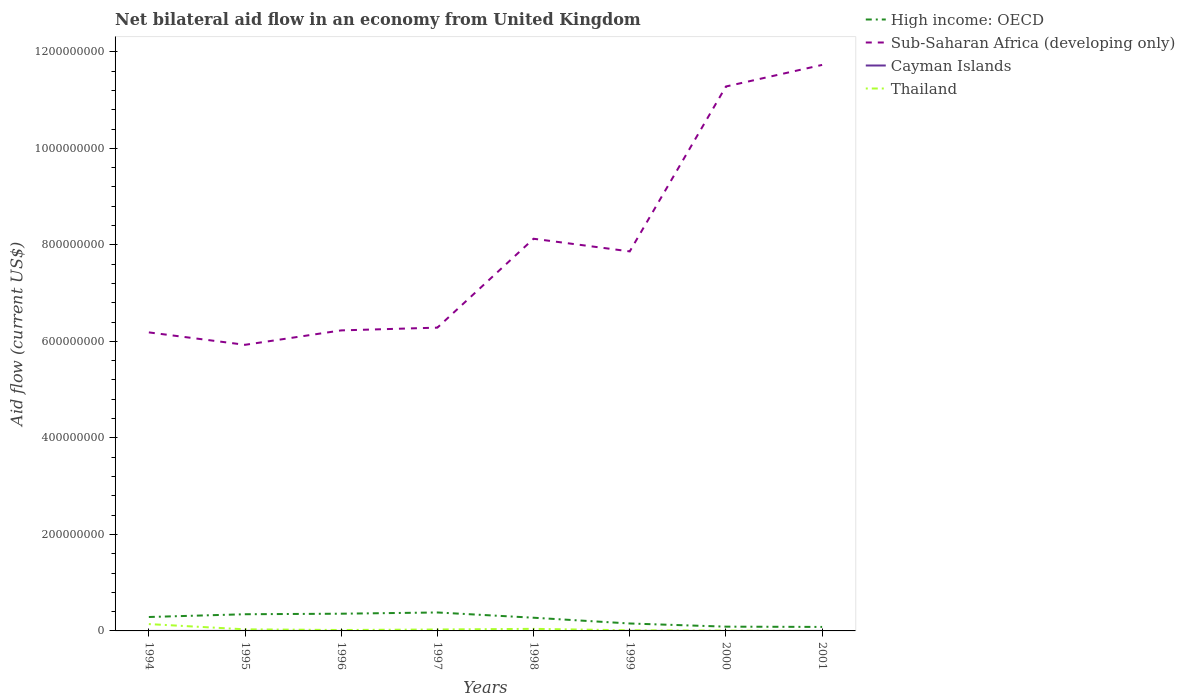How many different coloured lines are there?
Offer a very short reply. 4. Across all years, what is the maximum net bilateral aid flow in High income: OECD?
Keep it short and to the point. 8.28e+06. What is the total net bilateral aid flow in Thailand in the graph?
Keep it short and to the point. 1.29e+07. What is the difference between the highest and the second highest net bilateral aid flow in Sub-Saharan Africa (developing only)?
Keep it short and to the point. 5.80e+08. What is the difference between the highest and the lowest net bilateral aid flow in Thailand?
Keep it short and to the point. 2. How many lines are there?
Provide a short and direct response. 4. Does the graph contain grids?
Provide a short and direct response. No. Where does the legend appear in the graph?
Make the answer very short. Top right. How many legend labels are there?
Keep it short and to the point. 4. What is the title of the graph?
Your response must be concise. Net bilateral aid flow in an economy from United Kingdom. What is the label or title of the Y-axis?
Your answer should be very brief. Aid flow (current US$). What is the Aid flow (current US$) in High income: OECD in 1994?
Your answer should be very brief. 2.88e+07. What is the Aid flow (current US$) of Sub-Saharan Africa (developing only) in 1994?
Keep it short and to the point. 6.19e+08. What is the Aid flow (current US$) in Cayman Islands in 1994?
Keep it short and to the point. 0. What is the Aid flow (current US$) in Thailand in 1994?
Offer a terse response. 1.42e+07. What is the Aid flow (current US$) of High income: OECD in 1995?
Offer a terse response. 3.46e+07. What is the Aid flow (current US$) of Sub-Saharan Africa (developing only) in 1995?
Provide a short and direct response. 5.93e+08. What is the Aid flow (current US$) in Thailand in 1995?
Ensure brevity in your answer.  3.30e+06. What is the Aid flow (current US$) in High income: OECD in 1996?
Give a very brief answer. 3.57e+07. What is the Aid flow (current US$) in Sub-Saharan Africa (developing only) in 1996?
Your answer should be very brief. 6.23e+08. What is the Aid flow (current US$) of Thailand in 1996?
Your response must be concise. 1.92e+06. What is the Aid flow (current US$) of High income: OECD in 1997?
Give a very brief answer. 3.82e+07. What is the Aid flow (current US$) in Sub-Saharan Africa (developing only) in 1997?
Your answer should be compact. 6.28e+08. What is the Aid flow (current US$) of Thailand in 1997?
Offer a very short reply. 2.97e+06. What is the Aid flow (current US$) in High income: OECD in 1998?
Make the answer very short. 2.73e+07. What is the Aid flow (current US$) in Sub-Saharan Africa (developing only) in 1998?
Keep it short and to the point. 8.13e+08. What is the Aid flow (current US$) of Thailand in 1998?
Offer a terse response. 4.31e+06. What is the Aid flow (current US$) of High income: OECD in 1999?
Make the answer very short. 1.54e+07. What is the Aid flow (current US$) in Sub-Saharan Africa (developing only) in 1999?
Offer a terse response. 7.86e+08. What is the Aid flow (current US$) in Thailand in 1999?
Keep it short and to the point. 1.31e+06. What is the Aid flow (current US$) of High income: OECD in 2000?
Ensure brevity in your answer.  8.84e+06. What is the Aid flow (current US$) in Sub-Saharan Africa (developing only) in 2000?
Give a very brief answer. 1.13e+09. What is the Aid flow (current US$) of Cayman Islands in 2000?
Offer a very short reply. 0. What is the Aid flow (current US$) of Thailand in 2000?
Ensure brevity in your answer.  6.80e+05. What is the Aid flow (current US$) of High income: OECD in 2001?
Offer a terse response. 8.28e+06. What is the Aid flow (current US$) in Sub-Saharan Africa (developing only) in 2001?
Offer a terse response. 1.17e+09. What is the Aid flow (current US$) in Cayman Islands in 2001?
Offer a terse response. 0. What is the Aid flow (current US$) in Thailand in 2001?
Give a very brief answer. 0. Across all years, what is the maximum Aid flow (current US$) of High income: OECD?
Keep it short and to the point. 3.82e+07. Across all years, what is the maximum Aid flow (current US$) of Sub-Saharan Africa (developing only)?
Your answer should be compact. 1.17e+09. Across all years, what is the maximum Aid flow (current US$) of Thailand?
Give a very brief answer. 1.42e+07. Across all years, what is the minimum Aid flow (current US$) of High income: OECD?
Provide a short and direct response. 8.28e+06. Across all years, what is the minimum Aid flow (current US$) in Sub-Saharan Africa (developing only)?
Offer a terse response. 5.93e+08. Across all years, what is the minimum Aid flow (current US$) of Cayman Islands?
Your answer should be very brief. 0. What is the total Aid flow (current US$) of High income: OECD in the graph?
Offer a terse response. 1.97e+08. What is the total Aid flow (current US$) in Sub-Saharan Africa (developing only) in the graph?
Make the answer very short. 6.36e+09. What is the total Aid flow (current US$) in Cayman Islands in the graph?
Provide a succinct answer. 1.50e+05. What is the total Aid flow (current US$) of Thailand in the graph?
Give a very brief answer. 2.87e+07. What is the difference between the Aid flow (current US$) in High income: OECD in 1994 and that in 1995?
Your answer should be very brief. -5.72e+06. What is the difference between the Aid flow (current US$) in Sub-Saharan Africa (developing only) in 1994 and that in 1995?
Your answer should be compact. 2.58e+07. What is the difference between the Aid flow (current US$) in Thailand in 1994 and that in 1995?
Your answer should be very brief. 1.09e+07. What is the difference between the Aid flow (current US$) of High income: OECD in 1994 and that in 1996?
Provide a short and direct response. -6.82e+06. What is the difference between the Aid flow (current US$) of Sub-Saharan Africa (developing only) in 1994 and that in 1996?
Provide a short and direct response. -4.14e+06. What is the difference between the Aid flow (current US$) of Thailand in 1994 and that in 1996?
Give a very brief answer. 1.22e+07. What is the difference between the Aid flow (current US$) of High income: OECD in 1994 and that in 1997?
Offer a very short reply. -9.38e+06. What is the difference between the Aid flow (current US$) of Sub-Saharan Africa (developing only) in 1994 and that in 1997?
Your answer should be compact. -9.84e+06. What is the difference between the Aid flow (current US$) in Thailand in 1994 and that in 1997?
Offer a terse response. 1.12e+07. What is the difference between the Aid flow (current US$) in High income: OECD in 1994 and that in 1998?
Make the answer very short. 1.51e+06. What is the difference between the Aid flow (current US$) of Sub-Saharan Africa (developing only) in 1994 and that in 1998?
Make the answer very short. -1.94e+08. What is the difference between the Aid flow (current US$) of Thailand in 1994 and that in 1998?
Your response must be concise. 9.86e+06. What is the difference between the Aid flow (current US$) in High income: OECD in 1994 and that in 1999?
Give a very brief answer. 1.34e+07. What is the difference between the Aid flow (current US$) of Sub-Saharan Africa (developing only) in 1994 and that in 1999?
Your answer should be compact. -1.68e+08. What is the difference between the Aid flow (current US$) of Thailand in 1994 and that in 1999?
Your answer should be compact. 1.29e+07. What is the difference between the Aid flow (current US$) in High income: OECD in 1994 and that in 2000?
Your answer should be very brief. 2.00e+07. What is the difference between the Aid flow (current US$) of Sub-Saharan Africa (developing only) in 1994 and that in 2000?
Make the answer very short. -5.10e+08. What is the difference between the Aid flow (current US$) of Thailand in 1994 and that in 2000?
Ensure brevity in your answer.  1.35e+07. What is the difference between the Aid flow (current US$) of High income: OECD in 1994 and that in 2001?
Keep it short and to the point. 2.06e+07. What is the difference between the Aid flow (current US$) in Sub-Saharan Africa (developing only) in 1994 and that in 2001?
Keep it short and to the point. -5.54e+08. What is the difference between the Aid flow (current US$) of High income: OECD in 1995 and that in 1996?
Offer a very short reply. -1.10e+06. What is the difference between the Aid flow (current US$) of Sub-Saharan Africa (developing only) in 1995 and that in 1996?
Provide a short and direct response. -2.99e+07. What is the difference between the Aid flow (current US$) of Thailand in 1995 and that in 1996?
Give a very brief answer. 1.38e+06. What is the difference between the Aid flow (current US$) of High income: OECD in 1995 and that in 1997?
Provide a short and direct response. -3.66e+06. What is the difference between the Aid flow (current US$) of Sub-Saharan Africa (developing only) in 1995 and that in 1997?
Give a very brief answer. -3.56e+07. What is the difference between the Aid flow (current US$) in Thailand in 1995 and that in 1997?
Provide a short and direct response. 3.30e+05. What is the difference between the Aid flow (current US$) of High income: OECD in 1995 and that in 1998?
Your answer should be very brief. 7.23e+06. What is the difference between the Aid flow (current US$) of Sub-Saharan Africa (developing only) in 1995 and that in 1998?
Ensure brevity in your answer.  -2.20e+08. What is the difference between the Aid flow (current US$) in Thailand in 1995 and that in 1998?
Your response must be concise. -1.01e+06. What is the difference between the Aid flow (current US$) of High income: OECD in 1995 and that in 1999?
Your response must be concise. 1.92e+07. What is the difference between the Aid flow (current US$) in Sub-Saharan Africa (developing only) in 1995 and that in 1999?
Your answer should be compact. -1.94e+08. What is the difference between the Aid flow (current US$) of Cayman Islands in 1995 and that in 1999?
Provide a succinct answer. -10000. What is the difference between the Aid flow (current US$) of Thailand in 1995 and that in 1999?
Your answer should be very brief. 1.99e+06. What is the difference between the Aid flow (current US$) of High income: OECD in 1995 and that in 2000?
Provide a succinct answer. 2.57e+07. What is the difference between the Aid flow (current US$) in Sub-Saharan Africa (developing only) in 1995 and that in 2000?
Offer a terse response. -5.35e+08. What is the difference between the Aid flow (current US$) of Thailand in 1995 and that in 2000?
Your response must be concise. 2.62e+06. What is the difference between the Aid flow (current US$) of High income: OECD in 1995 and that in 2001?
Your answer should be compact. 2.63e+07. What is the difference between the Aid flow (current US$) in Sub-Saharan Africa (developing only) in 1995 and that in 2001?
Provide a short and direct response. -5.80e+08. What is the difference between the Aid flow (current US$) in High income: OECD in 1996 and that in 1997?
Your answer should be compact. -2.56e+06. What is the difference between the Aid flow (current US$) of Sub-Saharan Africa (developing only) in 1996 and that in 1997?
Your answer should be very brief. -5.70e+06. What is the difference between the Aid flow (current US$) in Thailand in 1996 and that in 1997?
Provide a succinct answer. -1.05e+06. What is the difference between the Aid flow (current US$) of High income: OECD in 1996 and that in 1998?
Ensure brevity in your answer.  8.33e+06. What is the difference between the Aid flow (current US$) of Sub-Saharan Africa (developing only) in 1996 and that in 1998?
Your answer should be very brief. -1.90e+08. What is the difference between the Aid flow (current US$) in Thailand in 1996 and that in 1998?
Offer a terse response. -2.39e+06. What is the difference between the Aid flow (current US$) in High income: OECD in 1996 and that in 1999?
Give a very brief answer. 2.03e+07. What is the difference between the Aid flow (current US$) of Sub-Saharan Africa (developing only) in 1996 and that in 1999?
Make the answer very short. -1.64e+08. What is the difference between the Aid flow (current US$) in Thailand in 1996 and that in 1999?
Your answer should be compact. 6.10e+05. What is the difference between the Aid flow (current US$) of High income: OECD in 1996 and that in 2000?
Make the answer very short. 2.68e+07. What is the difference between the Aid flow (current US$) in Sub-Saharan Africa (developing only) in 1996 and that in 2000?
Keep it short and to the point. -5.05e+08. What is the difference between the Aid flow (current US$) of Thailand in 1996 and that in 2000?
Your answer should be very brief. 1.24e+06. What is the difference between the Aid flow (current US$) of High income: OECD in 1996 and that in 2001?
Make the answer very short. 2.74e+07. What is the difference between the Aid flow (current US$) of Sub-Saharan Africa (developing only) in 1996 and that in 2001?
Ensure brevity in your answer.  -5.50e+08. What is the difference between the Aid flow (current US$) of High income: OECD in 1997 and that in 1998?
Provide a short and direct response. 1.09e+07. What is the difference between the Aid flow (current US$) in Sub-Saharan Africa (developing only) in 1997 and that in 1998?
Your answer should be compact. -1.84e+08. What is the difference between the Aid flow (current US$) in Thailand in 1997 and that in 1998?
Ensure brevity in your answer.  -1.34e+06. What is the difference between the Aid flow (current US$) in High income: OECD in 1997 and that in 1999?
Your response must be concise. 2.28e+07. What is the difference between the Aid flow (current US$) of Sub-Saharan Africa (developing only) in 1997 and that in 1999?
Offer a very short reply. -1.58e+08. What is the difference between the Aid flow (current US$) of Thailand in 1997 and that in 1999?
Make the answer very short. 1.66e+06. What is the difference between the Aid flow (current US$) in High income: OECD in 1997 and that in 2000?
Your response must be concise. 2.94e+07. What is the difference between the Aid flow (current US$) of Sub-Saharan Africa (developing only) in 1997 and that in 2000?
Ensure brevity in your answer.  -5.00e+08. What is the difference between the Aid flow (current US$) of Thailand in 1997 and that in 2000?
Make the answer very short. 2.29e+06. What is the difference between the Aid flow (current US$) of High income: OECD in 1997 and that in 2001?
Provide a succinct answer. 3.00e+07. What is the difference between the Aid flow (current US$) of Sub-Saharan Africa (developing only) in 1997 and that in 2001?
Your answer should be very brief. -5.44e+08. What is the difference between the Aid flow (current US$) of High income: OECD in 1998 and that in 1999?
Your answer should be compact. 1.19e+07. What is the difference between the Aid flow (current US$) of Sub-Saharan Africa (developing only) in 1998 and that in 1999?
Make the answer very short. 2.62e+07. What is the difference between the Aid flow (current US$) in Thailand in 1998 and that in 1999?
Provide a short and direct response. 3.00e+06. What is the difference between the Aid flow (current US$) in High income: OECD in 1998 and that in 2000?
Offer a terse response. 1.85e+07. What is the difference between the Aid flow (current US$) of Sub-Saharan Africa (developing only) in 1998 and that in 2000?
Your response must be concise. -3.15e+08. What is the difference between the Aid flow (current US$) of Thailand in 1998 and that in 2000?
Ensure brevity in your answer.  3.63e+06. What is the difference between the Aid flow (current US$) in High income: OECD in 1998 and that in 2001?
Keep it short and to the point. 1.91e+07. What is the difference between the Aid flow (current US$) of Sub-Saharan Africa (developing only) in 1998 and that in 2001?
Give a very brief answer. -3.60e+08. What is the difference between the Aid flow (current US$) in High income: OECD in 1999 and that in 2000?
Offer a terse response. 6.56e+06. What is the difference between the Aid flow (current US$) of Sub-Saharan Africa (developing only) in 1999 and that in 2000?
Ensure brevity in your answer.  -3.42e+08. What is the difference between the Aid flow (current US$) in Thailand in 1999 and that in 2000?
Offer a very short reply. 6.30e+05. What is the difference between the Aid flow (current US$) in High income: OECD in 1999 and that in 2001?
Your answer should be very brief. 7.12e+06. What is the difference between the Aid flow (current US$) in Sub-Saharan Africa (developing only) in 1999 and that in 2001?
Offer a terse response. -3.86e+08. What is the difference between the Aid flow (current US$) of High income: OECD in 2000 and that in 2001?
Your answer should be very brief. 5.60e+05. What is the difference between the Aid flow (current US$) in Sub-Saharan Africa (developing only) in 2000 and that in 2001?
Give a very brief answer. -4.47e+07. What is the difference between the Aid flow (current US$) of High income: OECD in 1994 and the Aid flow (current US$) of Sub-Saharan Africa (developing only) in 1995?
Offer a terse response. -5.64e+08. What is the difference between the Aid flow (current US$) of High income: OECD in 1994 and the Aid flow (current US$) of Cayman Islands in 1995?
Offer a very short reply. 2.88e+07. What is the difference between the Aid flow (current US$) in High income: OECD in 1994 and the Aid flow (current US$) in Thailand in 1995?
Your response must be concise. 2.56e+07. What is the difference between the Aid flow (current US$) of Sub-Saharan Africa (developing only) in 1994 and the Aid flow (current US$) of Cayman Islands in 1995?
Make the answer very short. 6.19e+08. What is the difference between the Aid flow (current US$) of Sub-Saharan Africa (developing only) in 1994 and the Aid flow (current US$) of Thailand in 1995?
Keep it short and to the point. 6.15e+08. What is the difference between the Aid flow (current US$) in High income: OECD in 1994 and the Aid flow (current US$) in Sub-Saharan Africa (developing only) in 1996?
Give a very brief answer. -5.94e+08. What is the difference between the Aid flow (current US$) of High income: OECD in 1994 and the Aid flow (current US$) of Thailand in 1996?
Provide a succinct answer. 2.69e+07. What is the difference between the Aid flow (current US$) in Sub-Saharan Africa (developing only) in 1994 and the Aid flow (current US$) in Thailand in 1996?
Your response must be concise. 6.17e+08. What is the difference between the Aid flow (current US$) in High income: OECD in 1994 and the Aid flow (current US$) in Sub-Saharan Africa (developing only) in 1997?
Your answer should be compact. -6.00e+08. What is the difference between the Aid flow (current US$) in High income: OECD in 1994 and the Aid flow (current US$) in Thailand in 1997?
Your response must be concise. 2.59e+07. What is the difference between the Aid flow (current US$) of Sub-Saharan Africa (developing only) in 1994 and the Aid flow (current US$) of Thailand in 1997?
Provide a succinct answer. 6.16e+08. What is the difference between the Aid flow (current US$) in High income: OECD in 1994 and the Aid flow (current US$) in Sub-Saharan Africa (developing only) in 1998?
Offer a terse response. -7.84e+08. What is the difference between the Aid flow (current US$) in High income: OECD in 1994 and the Aid flow (current US$) in Thailand in 1998?
Provide a succinct answer. 2.45e+07. What is the difference between the Aid flow (current US$) of Sub-Saharan Africa (developing only) in 1994 and the Aid flow (current US$) of Thailand in 1998?
Make the answer very short. 6.14e+08. What is the difference between the Aid flow (current US$) in High income: OECD in 1994 and the Aid flow (current US$) in Sub-Saharan Africa (developing only) in 1999?
Make the answer very short. -7.58e+08. What is the difference between the Aid flow (current US$) of High income: OECD in 1994 and the Aid flow (current US$) of Cayman Islands in 1999?
Offer a terse response. 2.88e+07. What is the difference between the Aid flow (current US$) in High income: OECD in 1994 and the Aid flow (current US$) in Thailand in 1999?
Your response must be concise. 2.75e+07. What is the difference between the Aid flow (current US$) in Sub-Saharan Africa (developing only) in 1994 and the Aid flow (current US$) in Cayman Islands in 1999?
Keep it short and to the point. 6.19e+08. What is the difference between the Aid flow (current US$) of Sub-Saharan Africa (developing only) in 1994 and the Aid flow (current US$) of Thailand in 1999?
Offer a terse response. 6.17e+08. What is the difference between the Aid flow (current US$) of High income: OECD in 1994 and the Aid flow (current US$) of Sub-Saharan Africa (developing only) in 2000?
Your answer should be compact. -1.10e+09. What is the difference between the Aid flow (current US$) of High income: OECD in 1994 and the Aid flow (current US$) of Thailand in 2000?
Offer a terse response. 2.82e+07. What is the difference between the Aid flow (current US$) of Sub-Saharan Africa (developing only) in 1994 and the Aid flow (current US$) of Thailand in 2000?
Your response must be concise. 6.18e+08. What is the difference between the Aid flow (current US$) of High income: OECD in 1994 and the Aid flow (current US$) of Sub-Saharan Africa (developing only) in 2001?
Give a very brief answer. -1.14e+09. What is the difference between the Aid flow (current US$) of High income: OECD in 1995 and the Aid flow (current US$) of Sub-Saharan Africa (developing only) in 1996?
Your answer should be compact. -5.88e+08. What is the difference between the Aid flow (current US$) of High income: OECD in 1995 and the Aid flow (current US$) of Thailand in 1996?
Your response must be concise. 3.26e+07. What is the difference between the Aid flow (current US$) in Sub-Saharan Africa (developing only) in 1995 and the Aid flow (current US$) in Thailand in 1996?
Offer a terse response. 5.91e+08. What is the difference between the Aid flow (current US$) in Cayman Islands in 1995 and the Aid flow (current US$) in Thailand in 1996?
Offer a terse response. -1.85e+06. What is the difference between the Aid flow (current US$) in High income: OECD in 1995 and the Aid flow (current US$) in Sub-Saharan Africa (developing only) in 1997?
Your answer should be compact. -5.94e+08. What is the difference between the Aid flow (current US$) of High income: OECD in 1995 and the Aid flow (current US$) of Thailand in 1997?
Provide a short and direct response. 3.16e+07. What is the difference between the Aid flow (current US$) of Sub-Saharan Africa (developing only) in 1995 and the Aid flow (current US$) of Thailand in 1997?
Offer a terse response. 5.90e+08. What is the difference between the Aid flow (current US$) of Cayman Islands in 1995 and the Aid flow (current US$) of Thailand in 1997?
Your response must be concise. -2.90e+06. What is the difference between the Aid flow (current US$) of High income: OECD in 1995 and the Aid flow (current US$) of Sub-Saharan Africa (developing only) in 1998?
Your answer should be very brief. -7.78e+08. What is the difference between the Aid flow (current US$) of High income: OECD in 1995 and the Aid flow (current US$) of Thailand in 1998?
Your answer should be compact. 3.03e+07. What is the difference between the Aid flow (current US$) in Sub-Saharan Africa (developing only) in 1995 and the Aid flow (current US$) in Thailand in 1998?
Provide a short and direct response. 5.89e+08. What is the difference between the Aid flow (current US$) of Cayman Islands in 1995 and the Aid flow (current US$) of Thailand in 1998?
Keep it short and to the point. -4.24e+06. What is the difference between the Aid flow (current US$) in High income: OECD in 1995 and the Aid flow (current US$) in Sub-Saharan Africa (developing only) in 1999?
Provide a short and direct response. -7.52e+08. What is the difference between the Aid flow (current US$) of High income: OECD in 1995 and the Aid flow (current US$) of Cayman Islands in 1999?
Provide a short and direct response. 3.45e+07. What is the difference between the Aid flow (current US$) in High income: OECD in 1995 and the Aid flow (current US$) in Thailand in 1999?
Make the answer very short. 3.33e+07. What is the difference between the Aid flow (current US$) of Sub-Saharan Africa (developing only) in 1995 and the Aid flow (current US$) of Cayman Islands in 1999?
Your answer should be compact. 5.93e+08. What is the difference between the Aid flow (current US$) of Sub-Saharan Africa (developing only) in 1995 and the Aid flow (current US$) of Thailand in 1999?
Give a very brief answer. 5.92e+08. What is the difference between the Aid flow (current US$) in Cayman Islands in 1995 and the Aid flow (current US$) in Thailand in 1999?
Provide a succinct answer. -1.24e+06. What is the difference between the Aid flow (current US$) in High income: OECD in 1995 and the Aid flow (current US$) in Sub-Saharan Africa (developing only) in 2000?
Provide a succinct answer. -1.09e+09. What is the difference between the Aid flow (current US$) in High income: OECD in 1995 and the Aid flow (current US$) in Thailand in 2000?
Your answer should be compact. 3.39e+07. What is the difference between the Aid flow (current US$) in Sub-Saharan Africa (developing only) in 1995 and the Aid flow (current US$) in Thailand in 2000?
Provide a short and direct response. 5.92e+08. What is the difference between the Aid flow (current US$) in Cayman Islands in 1995 and the Aid flow (current US$) in Thailand in 2000?
Make the answer very short. -6.10e+05. What is the difference between the Aid flow (current US$) of High income: OECD in 1995 and the Aid flow (current US$) of Sub-Saharan Africa (developing only) in 2001?
Provide a succinct answer. -1.14e+09. What is the difference between the Aid flow (current US$) of High income: OECD in 1996 and the Aid flow (current US$) of Sub-Saharan Africa (developing only) in 1997?
Offer a terse response. -5.93e+08. What is the difference between the Aid flow (current US$) of High income: OECD in 1996 and the Aid flow (current US$) of Thailand in 1997?
Offer a terse response. 3.27e+07. What is the difference between the Aid flow (current US$) in Sub-Saharan Africa (developing only) in 1996 and the Aid flow (current US$) in Thailand in 1997?
Make the answer very short. 6.20e+08. What is the difference between the Aid flow (current US$) of High income: OECD in 1996 and the Aid flow (current US$) of Sub-Saharan Africa (developing only) in 1998?
Your answer should be very brief. -7.77e+08. What is the difference between the Aid flow (current US$) in High income: OECD in 1996 and the Aid flow (current US$) in Thailand in 1998?
Give a very brief answer. 3.14e+07. What is the difference between the Aid flow (current US$) of Sub-Saharan Africa (developing only) in 1996 and the Aid flow (current US$) of Thailand in 1998?
Provide a short and direct response. 6.18e+08. What is the difference between the Aid flow (current US$) in High income: OECD in 1996 and the Aid flow (current US$) in Sub-Saharan Africa (developing only) in 1999?
Offer a very short reply. -7.51e+08. What is the difference between the Aid flow (current US$) of High income: OECD in 1996 and the Aid flow (current US$) of Cayman Islands in 1999?
Provide a succinct answer. 3.56e+07. What is the difference between the Aid flow (current US$) of High income: OECD in 1996 and the Aid flow (current US$) of Thailand in 1999?
Your response must be concise. 3.44e+07. What is the difference between the Aid flow (current US$) in Sub-Saharan Africa (developing only) in 1996 and the Aid flow (current US$) in Cayman Islands in 1999?
Your answer should be compact. 6.23e+08. What is the difference between the Aid flow (current US$) of Sub-Saharan Africa (developing only) in 1996 and the Aid flow (current US$) of Thailand in 1999?
Offer a very short reply. 6.21e+08. What is the difference between the Aid flow (current US$) in High income: OECD in 1996 and the Aid flow (current US$) in Sub-Saharan Africa (developing only) in 2000?
Your answer should be very brief. -1.09e+09. What is the difference between the Aid flow (current US$) in High income: OECD in 1996 and the Aid flow (current US$) in Thailand in 2000?
Give a very brief answer. 3.50e+07. What is the difference between the Aid flow (current US$) of Sub-Saharan Africa (developing only) in 1996 and the Aid flow (current US$) of Thailand in 2000?
Keep it short and to the point. 6.22e+08. What is the difference between the Aid flow (current US$) of High income: OECD in 1996 and the Aid flow (current US$) of Sub-Saharan Africa (developing only) in 2001?
Your answer should be compact. -1.14e+09. What is the difference between the Aid flow (current US$) in High income: OECD in 1997 and the Aid flow (current US$) in Sub-Saharan Africa (developing only) in 1998?
Give a very brief answer. -7.74e+08. What is the difference between the Aid flow (current US$) in High income: OECD in 1997 and the Aid flow (current US$) in Thailand in 1998?
Your response must be concise. 3.39e+07. What is the difference between the Aid flow (current US$) of Sub-Saharan Africa (developing only) in 1997 and the Aid flow (current US$) of Thailand in 1998?
Your answer should be very brief. 6.24e+08. What is the difference between the Aid flow (current US$) of High income: OECD in 1997 and the Aid flow (current US$) of Sub-Saharan Africa (developing only) in 1999?
Your answer should be very brief. -7.48e+08. What is the difference between the Aid flow (current US$) of High income: OECD in 1997 and the Aid flow (current US$) of Cayman Islands in 1999?
Your response must be concise. 3.82e+07. What is the difference between the Aid flow (current US$) in High income: OECD in 1997 and the Aid flow (current US$) in Thailand in 1999?
Provide a short and direct response. 3.69e+07. What is the difference between the Aid flow (current US$) in Sub-Saharan Africa (developing only) in 1997 and the Aid flow (current US$) in Cayman Islands in 1999?
Provide a succinct answer. 6.28e+08. What is the difference between the Aid flow (current US$) in Sub-Saharan Africa (developing only) in 1997 and the Aid flow (current US$) in Thailand in 1999?
Offer a terse response. 6.27e+08. What is the difference between the Aid flow (current US$) in High income: OECD in 1997 and the Aid flow (current US$) in Sub-Saharan Africa (developing only) in 2000?
Provide a short and direct response. -1.09e+09. What is the difference between the Aid flow (current US$) of High income: OECD in 1997 and the Aid flow (current US$) of Thailand in 2000?
Give a very brief answer. 3.76e+07. What is the difference between the Aid flow (current US$) of Sub-Saharan Africa (developing only) in 1997 and the Aid flow (current US$) of Thailand in 2000?
Your answer should be compact. 6.28e+08. What is the difference between the Aid flow (current US$) in High income: OECD in 1997 and the Aid flow (current US$) in Sub-Saharan Africa (developing only) in 2001?
Keep it short and to the point. -1.13e+09. What is the difference between the Aid flow (current US$) of High income: OECD in 1998 and the Aid flow (current US$) of Sub-Saharan Africa (developing only) in 1999?
Offer a very short reply. -7.59e+08. What is the difference between the Aid flow (current US$) in High income: OECD in 1998 and the Aid flow (current US$) in Cayman Islands in 1999?
Your answer should be compact. 2.73e+07. What is the difference between the Aid flow (current US$) of High income: OECD in 1998 and the Aid flow (current US$) of Thailand in 1999?
Your answer should be very brief. 2.60e+07. What is the difference between the Aid flow (current US$) in Sub-Saharan Africa (developing only) in 1998 and the Aid flow (current US$) in Cayman Islands in 1999?
Provide a short and direct response. 8.13e+08. What is the difference between the Aid flow (current US$) of Sub-Saharan Africa (developing only) in 1998 and the Aid flow (current US$) of Thailand in 1999?
Provide a short and direct response. 8.11e+08. What is the difference between the Aid flow (current US$) in High income: OECD in 1998 and the Aid flow (current US$) in Sub-Saharan Africa (developing only) in 2000?
Your answer should be very brief. -1.10e+09. What is the difference between the Aid flow (current US$) of High income: OECD in 1998 and the Aid flow (current US$) of Thailand in 2000?
Your answer should be very brief. 2.67e+07. What is the difference between the Aid flow (current US$) of Sub-Saharan Africa (developing only) in 1998 and the Aid flow (current US$) of Thailand in 2000?
Ensure brevity in your answer.  8.12e+08. What is the difference between the Aid flow (current US$) in High income: OECD in 1998 and the Aid flow (current US$) in Sub-Saharan Africa (developing only) in 2001?
Provide a succinct answer. -1.15e+09. What is the difference between the Aid flow (current US$) in High income: OECD in 1999 and the Aid flow (current US$) in Sub-Saharan Africa (developing only) in 2000?
Ensure brevity in your answer.  -1.11e+09. What is the difference between the Aid flow (current US$) in High income: OECD in 1999 and the Aid flow (current US$) in Thailand in 2000?
Give a very brief answer. 1.47e+07. What is the difference between the Aid flow (current US$) in Sub-Saharan Africa (developing only) in 1999 and the Aid flow (current US$) in Thailand in 2000?
Offer a very short reply. 7.86e+08. What is the difference between the Aid flow (current US$) in Cayman Islands in 1999 and the Aid flow (current US$) in Thailand in 2000?
Offer a very short reply. -6.00e+05. What is the difference between the Aid flow (current US$) of High income: OECD in 1999 and the Aid flow (current US$) of Sub-Saharan Africa (developing only) in 2001?
Make the answer very short. -1.16e+09. What is the difference between the Aid flow (current US$) of High income: OECD in 2000 and the Aid flow (current US$) of Sub-Saharan Africa (developing only) in 2001?
Give a very brief answer. -1.16e+09. What is the average Aid flow (current US$) of High income: OECD per year?
Keep it short and to the point. 2.46e+07. What is the average Aid flow (current US$) of Sub-Saharan Africa (developing only) per year?
Provide a succinct answer. 7.95e+08. What is the average Aid flow (current US$) in Cayman Islands per year?
Keep it short and to the point. 1.88e+04. What is the average Aid flow (current US$) of Thailand per year?
Your answer should be compact. 3.58e+06. In the year 1994, what is the difference between the Aid flow (current US$) of High income: OECD and Aid flow (current US$) of Sub-Saharan Africa (developing only)?
Your answer should be compact. -5.90e+08. In the year 1994, what is the difference between the Aid flow (current US$) in High income: OECD and Aid flow (current US$) in Thailand?
Your answer should be very brief. 1.47e+07. In the year 1994, what is the difference between the Aid flow (current US$) of Sub-Saharan Africa (developing only) and Aid flow (current US$) of Thailand?
Provide a succinct answer. 6.04e+08. In the year 1995, what is the difference between the Aid flow (current US$) of High income: OECD and Aid flow (current US$) of Sub-Saharan Africa (developing only)?
Provide a short and direct response. -5.58e+08. In the year 1995, what is the difference between the Aid flow (current US$) of High income: OECD and Aid flow (current US$) of Cayman Islands?
Offer a terse response. 3.45e+07. In the year 1995, what is the difference between the Aid flow (current US$) in High income: OECD and Aid flow (current US$) in Thailand?
Offer a very short reply. 3.13e+07. In the year 1995, what is the difference between the Aid flow (current US$) in Sub-Saharan Africa (developing only) and Aid flow (current US$) in Cayman Islands?
Provide a succinct answer. 5.93e+08. In the year 1995, what is the difference between the Aid flow (current US$) of Sub-Saharan Africa (developing only) and Aid flow (current US$) of Thailand?
Your answer should be compact. 5.90e+08. In the year 1995, what is the difference between the Aid flow (current US$) of Cayman Islands and Aid flow (current US$) of Thailand?
Give a very brief answer. -3.23e+06. In the year 1996, what is the difference between the Aid flow (current US$) of High income: OECD and Aid flow (current US$) of Sub-Saharan Africa (developing only)?
Ensure brevity in your answer.  -5.87e+08. In the year 1996, what is the difference between the Aid flow (current US$) in High income: OECD and Aid flow (current US$) in Thailand?
Your response must be concise. 3.38e+07. In the year 1996, what is the difference between the Aid flow (current US$) in Sub-Saharan Africa (developing only) and Aid flow (current US$) in Thailand?
Make the answer very short. 6.21e+08. In the year 1997, what is the difference between the Aid flow (current US$) in High income: OECD and Aid flow (current US$) in Sub-Saharan Africa (developing only)?
Offer a terse response. -5.90e+08. In the year 1997, what is the difference between the Aid flow (current US$) in High income: OECD and Aid flow (current US$) in Thailand?
Make the answer very short. 3.53e+07. In the year 1997, what is the difference between the Aid flow (current US$) of Sub-Saharan Africa (developing only) and Aid flow (current US$) of Thailand?
Make the answer very short. 6.25e+08. In the year 1998, what is the difference between the Aid flow (current US$) in High income: OECD and Aid flow (current US$) in Sub-Saharan Africa (developing only)?
Give a very brief answer. -7.85e+08. In the year 1998, what is the difference between the Aid flow (current US$) of High income: OECD and Aid flow (current US$) of Thailand?
Your answer should be compact. 2.30e+07. In the year 1998, what is the difference between the Aid flow (current US$) of Sub-Saharan Africa (developing only) and Aid flow (current US$) of Thailand?
Offer a terse response. 8.08e+08. In the year 1999, what is the difference between the Aid flow (current US$) of High income: OECD and Aid flow (current US$) of Sub-Saharan Africa (developing only)?
Your answer should be very brief. -7.71e+08. In the year 1999, what is the difference between the Aid flow (current US$) of High income: OECD and Aid flow (current US$) of Cayman Islands?
Your answer should be compact. 1.53e+07. In the year 1999, what is the difference between the Aid flow (current US$) of High income: OECD and Aid flow (current US$) of Thailand?
Make the answer very short. 1.41e+07. In the year 1999, what is the difference between the Aid flow (current US$) of Sub-Saharan Africa (developing only) and Aid flow (current US$) of Cayman Islands?
Offer a very short reply. 7.86e+08. In the year 1999, what is the difference between the Aid flow (current US$) of Sub-Saharan Africa (developing only) and Aid flow (current US$) of Thailand?
Your answer should be very brief. 7.85e+08. In the year 1999, what is the difference between the Aid flow (current US$) of Cayman Islands and Aid flow (current US$) of Thailand?
Ensure brevity in your answer.  -1.23e+06. In the year 2000, what is the difference between the Aid flow (current US$) of High income: OECD and Aid flow (current US$) of Sub-Saharan Africa (developing only)?
Offer a terse response. -1.12e+09. In the year 2000, what is the difference between the Aid flow (current US$) of High income: OECD and Aid flow (current US$) of Thailand?
Provide a short and direct response. 8.16e+06. In the year 2000, what is the difference between the Aid flow (current US$) of Sub-Saharan Africa (developing only) and Aid flow (current US$) of Thailand?
Your answer should be very brief. 1.13e+09. In the year 2001, what is the difference between the Aid flow (current US$) of High income: OECD and Aid flow (current US$) of Sub-Saharan Africa (developing only)?
Ensure brevity in your answer.  -1.16e+09. What is the ratio of the Aid flow (current US$) in High income: OECD in 1994 to that in 1995?
Make the answer very short. 0.83. What is the ratio of the Aid flow (current US$) in Sub-Saharan Africa (developing only) in 1994 to that in 1995?
Give a very brief answer. 1.04. What is the ratio of the Aid flow (current US$) of Thailand in 1994 to that in 1995?
Ensure brevity in your answer.  4.29. What is the ratio of the Aid flow (current US$) of High income: OECD in 1994 to that in 1996?
Provide a succinct answer. 0.81. What is the ratio of the Aid flow (current US$) in Thailand in 1994 to that in 1996?
Your answer should be compact. 7.38. What is the ratio of the Aid flow (current US$) of High income: OECD in 1994 to that in 1997?
Offer a very short reply. 0.75. What is the ratio of the Aid flow (current US$) of Sub-Saharan Africa (developing only) in 1994 to that in 1997?
Your answer should be compact. 0.98. What is the ratio of the Aid flow (current US$) in Thailand in 1994 to that in 1997?
Provide a succinct answer. 4.77. What is the ratio of the Aid flow (current US$) of High income: OECD in 1994 to that in 1998?
Keep it short and to the point. 1.06. What is the ratio of the Aid flow (current US$) in Sub-Saharan Africa (developing only) in 1994 to that in 1998?
Your answer should be very brief. 0.76. What is the ratio of the Aid flow (current US$) in Thailand in 1994 to that in 1998?
Make the answer very short. 3.29. What is the ratio of the Aid flow (current US$) of High income: OECD in 1994 to that in 1999?
Provide a succinct answer. 1.87. What is the ratio of the Aid flow (current US$) of Sub-Saharan Africa (developing only) in 1994 to that in 1999?
Provide a short and direct response. 0.79. What is the ratio of the Aid flow (current US$) in Thailand in 1994 to that in 1999?
Your answer should be compact. 10.82. What is the ratio of the Aid flow (current US$) in High income: OECD in 1994 to that in 2000?
Give a very brief answer. 3.26. What is the ratio of the Aid flow (current US$) of Sub-Saharan Africa (developing only) in 1994 to that in 2000?
Keep it short and to the point. 0.55. What is the ratio of the Aid flow (current US$) of Thailand in 1994 to that in 2000?
Ensure brevity in your answer.  20.84. What is the ratio of the Aid flow (current US$) in High income: OECD in 1994 to that in 2001?
Offer a terse response. 3.48. What is the ratio of the Aid flow (current US$) of Sub-Saharan Africa (developing only) in 1994 to that in 2001?
Give a very brief answer. 0.53. What is the ratio of the Aid flow (current US$) in High income: OECD in 1995 to that in 1996?
Keep it short and to the point. 0.97. What is the ratio of the Aid flow (current US$) in Thailand in 1995 to that in 1996?
Make the answer very short. 1.72. What is the ratio of the Aid flow (current US$) of High income: OECD in 1995 to that in 1997?
Give a very brief answer. 0.9. What is the ratio of the Aid flow (current US$) of Sub-Saharan Africa (developing only) in 1995 to that in 1997?
Keep it short and to the point. 0.94. What is the ratio of the Aid flow (current US$) of High income: OECD in 1995 to that in 1998?
Your answer should be compact. 1.26. What is the ratio of the Aid flow (current US$) of Sub-Saharan Africa (developing only) in 1995 to that in 1998?
Your answer should be very brief. 0.73. What is the ratio of the Aid flow (current US$) in Thailand in 1995 to that in 1998?
Offer a terse response. 0.77. What is the ratio of the Aid flow (current US$) in High income: OECD in 1995 to that in 1999?
Make the answer very short. 2.24. What is the ratio of the Aid flow (current US$) of Sub-Saharan Africa (developing only) in 1995 to that in 1999?
Provide a short and direct response. 0.75. What is the ratio of the Aid flow (current US$) in Thailand in 1995 to that in 1999?
Offer a terse response. 2.52. What is the ratio of the Aid flow (current US$) in High income: OECD in 1995 to that in 2000?
Provide a succinct answer. 3.91. What is the ratio of the Aid flow (current US$) in Sub-Saharan Africa (developing only) in 1995 to that in 2000?
Give a very brief answer. 0.53. What is the ratio of the Aid flow (current US$) of Thailand in 1995 to that in 2000?
Keep it short and to the point. 4.85. What is the ratio of the Aid flow (current US$) in High income: OECD in 1995 to that in 2001?
Your response must be concise. 4.18. What is the ratio of the Aid flow (current US$) in Sub-Saharan Africa (developing only) in 1995 to that in 2001?
Provide a short and direct response. 0.51. What is the ratio of the Aid flow (current US$) in High income: OECD in 1996 to that in 1997?
Ensure brevity in your answer.  0.93. What is the ratio of the Aid flow (current US$) of Sub-Saharan Africa (developing only) in 1996 to that in 1997?
Ensure brevity in your answer.  0.99. What is the ratio of the Aid flow (current US$) in Thailand in 1996 to that in 1997?
Your response must be concise. 0.65. What is the ratio of the Aid flow (current US$) in High income: OECD in 1996 to that in 1998?
Offer a terse response. 1.3. What is the ratio of the Aid flow (current US$) of Sub-Saharan Africa (developing only) in 1996 to that in 1998?
Give a very brief answer. 0.77. What is the ratio of the Aid flow (current US$) in Thailand in 1996 to that in 1998?
Offer a very short reply. 0.45. What is the ratio of the Aid flow (current US$) of High income: OECD in 1996 to that in 1999?
Offer a very short reply. 2.32. What is the ratio of the Aid flow (current US$) in Sub-Saharan Africa (developing only) in 1996 to that in 1999?
Offer a terse response. 0.79. What is the ratio of the Aid flow (current US$) of Thailand in 1996 to that in 1999?
Provide a succinct answer. 1.47. What is the ratio of the Aid flow (current US$) in High income: OECD in 1996 to that in 2000?
Make the answer very short. 4.04. What is the ratio of the Aid flow (current US$) in Sub-Saharan Africa (developing only) in 1996 to that in 2000?
Make the answer very short. 0.55. What is the ratio of the Aid flow (current US$) of Thailand in 1996 to that in 2000?
Provide a short and direct response. 2.82. What is the ratio of the Aid flow (current US$) of High income: OECD in 1996 to that in 2001?
Provide a succinct answer. 4.31. What is the ratio of the Aid flow (current US$) in Sub-Saharan Africa (developing only) in 1996 to that in 2001?
Your response must be concise. 0.53. What is the ratio of the Aid flow (current US$) of High income: OECD in 1997 to that in 1998?
Your answer should be compact. 1.4. What is the ratio of the Aid flow (current US$) of Sub-Saharan Africa (developing only) in 1997 to that in 1998?
Your response must be concise. 0.77. What is the ratio of the Aid flow (current US$) in Thailand in 1997 to that in 1998?
Your response must be concise. 0.69. What is the ratio of the Aid flow (current US$) in High income: OECD in 1997 to that in 1999?
Your answer should be compact. 2.48. What is the ratio of the Aid flow (current US$) in Sub-Saharan Africa (developing only) in 1997 to that in 1999?
Ensure brevity in your answer.  0.8. What is the ratio of the Aid flow (current US$) in Thailand in 1997 to that in 1999?
Keep it short and to the point. 2.27. What is the ratio of the Aid flow (current US$) of High income: OECD in 1997 to that in 2000?
Provide a succinct answer. 4.32. What is the ratio of the Aid flow (current US$) of Sub-Saharan Africa (developing only) in 1997 to that in 2000?
Your response must be concise. 0.56. What is the ratio of the Aid flow (current US$) in Thailand in 1997 to that in 2000?
Your response must be concise. 4.37. What is the ratio of the Aid flow (current US$) in High income: OECD in 1997 to that in 2001?
Offer a very short reply. 4.62. What is the ratio of the Aid flow (current US$) of Sub-Saharan Africa (developing only) in 1997 to that in 2001?
Offer a terse response. 0.54. What is the ratio of the Aid flow (current US$) in High income: OECD in 1998 to that in 1999?
Keep it short and to the point. 1.78. What is the ratio of the Aid flow (current US$) in Sub-Saharan Africa (developing only) in 1998 to that in 1999?
Offer a terse response. 1.03. What is the ratio of the Aid flow (current US$) of Thailand in 1998 to that in 1999?
Make the answer very short. 3.29. What is the ratio of the Aid flow (current US$) in High income: OECD in 1998 to that in 2000?
Offer a terse response. 3.09. What is the ratio of the Aid flow (current US$) of Sub-Saharan Africa (developing only) in 1998 to that in 2000?
Offer a very short reply. 0.72. What is the ratio of the Aid flow (current US$) in Thailand in 1998 to that in 2000?
Offer a terse response. 6.34. What is the ratio of the Aid flow (current US$) in High income: OECD in 1998 to that in 2001?
Provide a succinct answer. 3.3. What is the ratio of the Aid flow (current US$) in Sub-Saharan Africa (developing only) in 1998 to that in 2001?
Make the answer very short. 0.69. What is the ratio of the Aid flow (current US$) of High income: OECD in 1999 to that in 2000?
Provide a succinct answer. 1.74. What is the ratio of the Aid flow (current US$) of Sub-Saharan Africa (developing only) in 1999 to that in 2000?
Make the answer very short. 0.7. What is the ratio of the Aid flow (current US$) of Thailand in 1999 to that in 2000?
Give a very brief answer. 1.93. What is the ratio of the Aid flow (current US$) in High income: OECD in 1999 to that in 2001?
Provide a succinct answer. 1.86. What is the ratio of the Aid flow (current US$) in Sub-Saharan Africa (developing only) in 1999 to that in 2001?
Your answer should be very brief. 0.67. What is the ratio of the Aid flow (current US$) of High income: OECD in 2000 to that in 2001?
Offer a terse response. 1.07. What is the ratio of the Aid flow (current US$) in Sub-Saharan Africa (developing only) in 2000 to that in 2001?
Provide a short and direct response. 0.96. What is the difference between the highest and the second highest Aid flow (current US$) of High income: OECD?
Ensure brevity in your answer.  2.56e+06. What is the difference between the highest and the second highest Aid flow (current US$) in Sub-Saharan Africa (developing only)?
Provide a short and direct response. 4.47e+07. What is the difference between the highest and the second highest Aid flow (current US$) in Thailand?
Ensure brevity in your answer.  9.86e+06. What is the difference between the highest and the lowest Aid flow (current US$) of High income: OECD?
Give a very brief answer. 3.00e+07. What is the difference between the highest and the lowest Aid flow (current US$) of Sub-Saharan Africa (developing only)?
Make the answer very short. 5.80e+08. What is the difference between the highest and the lowest Aid flow (current US$) in Cayman Islands?
Provide a succinct answer. 8.00e+04. What is the difference between the highest and the lowest Aid flow (current US$) in Thailand?
Provide a succinct answer. 1.42e+07. 